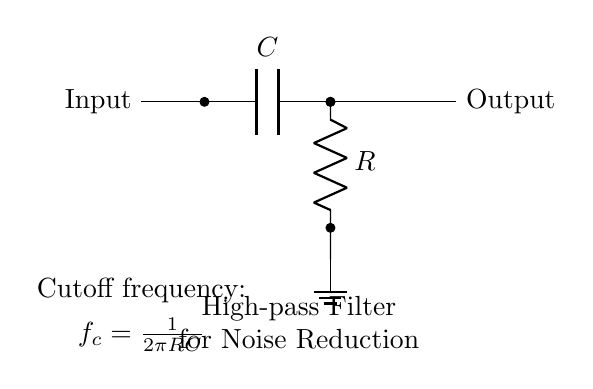What are the components in this circuit? The circuit contains a capacitor and a resistor, indicated by their symbols and labels in the diagram.
Answer: Capacitor, Resistor What is the purpose of this circuit? The circuit is designed as a high-pass filter for noise reduction in audio applications, as stated in the label at the bottom of the diagram.
Answer: High-pass filter for noise reduction What does the label "Cutoff frequency" refer to? It refers to the frequency at which the output signal begins to be attenuated, and it is calculated using the formula provided in the diagram.
Answer: Frequency at which output signal is attenuated How is the cutoff frequency calculated? The cutoff frequency is calculated using the formula \(f_c = \frac{1}{2\pi RC}\), which relates the resistor, capacitor, and the resulting frequency for filtering.
Answer: One over two pi RC What is the direction of signal flow in this circuit? The signal flows from the left (input) to the right (output), as shown by the arrows indicating direction in the circuit diagram.
Answer: Left to right What happens to signals below the cutoff frequency? Signals below the cutoff frequency are significantly attenuated or blocked while signals above this frequency are allowed to pass through.
Answer: Attenuated or blocked What type of filter is represented in this circuit? This circuit represents a high-pass filter, which allows higher frequencies to pass while rejecting lower frequencies, as indicated by its design and purpose.
Answer: High-pass filter 